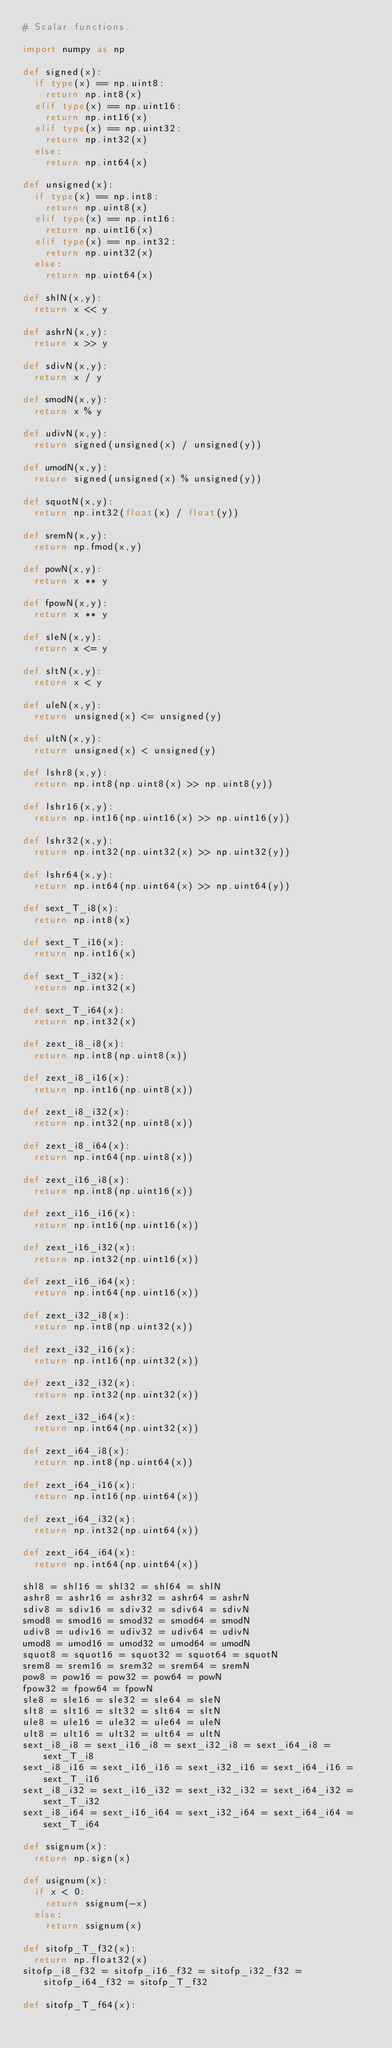<code> <loc_0><loc_0><loc_500><loc_500><_Python_># Scalar functions.

import numpy as np

def signed(x):
  if type(x) == np.uint8:
    return np.int8(x)
  elif type(x) == np.uint16:
    return np.int16(x)
  elif type(x) == np.uint32:
    return np.int32(x)
  else:
    return np.int64(x)

def unsigned(x):
  if type(x) == np.int8:
    return np.uint8(x)
  elif type(x) == np.int16:
    return np.uint16(x)
  elif type(x) == np.int32:
    return np.uint32(x)
  else:
    return np.uint64(x)

def shlN(x,y):
  return x << y

def ashrN(x,y):
  return x >> y

def sdivN(x,y):
  return x / y

def smodN(x,y):
  return x % y

def udivN(x,y):
  return signed(unsigned(x) / unsigned(y))

def umodN(x,y):
  return signed(unsigned(x) % unsigned(y))

def squotN(x,y):
  return np.int32(float(x) / float(y))

def sremN(x,y):
  return np.fmod(x,y)

def powN(x,y):
  return x ** y

def fpowN(x,y):
  return x ** y

def sleN(x,y):
  return x <= y

def sltN(x,y):
  return x < y

def uleN(x,y):
  return unsigned(x) <= unsigned(y)

def ultN(x,y):
  return unsigned(x) < unsigned(y)

def lshr8(x,y):
  return np.int8(np.uint8(x) >> np.uint8(y))

def lshr16(x,y):
  return np.int16(np.uint16(x) >> np.uint16(y))

def lshr32(x,y):
  return np.int32(np.uint32(x) >> np.uint32(y))

def lshr64(x,y):
  return np.int64(np.uint64(x) >> np.uint64(y))

def sext_T_i8(x):
  return np.int8(x)

def sext_T_i16(x):
  return np.int16(x)

def sext_T_i32(x):
  return np.int32(x)

def sext_T_i64(x):
  return np.int32(x)

def zext_i8_i8(x):
  return np.int8(np.uint8(x))

def zext_i8_i16(x):
  return np.int16(np.uint8(x))

def zext_i8_i32(x):
  return np.int32(np.uint8(x))

def zext_i8_i64(x):
  return np.int64(np.uint8(x))

def zext_i16_i8(x):
  return np.int8(np.uint16(x))

def zext_i16_i16(x):
  return np.int16(np.uint16(x))

def zext_i16_i32(x):
  return np.int32(np.uint16(x))

def zext_i16_i64(x):
  return np.int64(np.uint16(x))

def zext_i32_i8(x):
  return np.int8(np.uint32(x))

def zext_i32_i16(x):
  return np.int16(np.uint32(x))

def zext_i32_i32(x):
  return np.int32(np.uint32(x))

def zext_i32_i64(x):
  return np.int64(np.uint32(x))

def zext_i64_i8(x):
  return np.int8(np.uint64(x))

def zext_i64_i16(x):
  return np.int16(np.uint64(x))

def zext_i64_i32(x):
  return np.int32(np.uint64(x))

def zext_i64_i64(x):
  return np.int64(np.uint64(x))

shl8 = shl16 = shl32 = shl64 = shlN
ashr8 = ashr16 = ashr32 = ashr64 = ashrN
sdiv8 = sdiv16 = sdiv32 = sdiv64 = sdivN
smod8 = smod16 = smod32 = smod64 = smodN
udiv8 = udiv16 = udiv32 = udiv64 = udivN
umod8 = umod16 = umod32 = umod64 = umodN
squot8 = squot16 = squot32 = squot64 = squotN
srem8 = srem16 = srem32 = srem64 = sremN
pow8 = pow16 = pow32 = pow64 = powN
fpow32 = fpow64 = fpowN
sle8 = sle16 = sle32 = sle64 = sleN
slt8 = slt16 = slt32 = slt64 = sltN
ule8 = ule16 = ule32 = ule64 = uleN
ult8 = ult16 = ult32 = ult64 = ultN
sext_i8_i8 = sext_i16_i8 = sext_i32_i8 = sext_i64_i8 = sext_T_i8
sext_i8_i16 = sext_i16_i16 = sext_i32_i16 = sext_i64_i16 = sext_T_i16
sext_i8_i32 = sext_i16_i32 = sext_i32_i32 = sext_i64_i32 = sext_T_i32
sext_i8_i64 = sext_i16_i64 = sext_i32_i64 = sext_i64_i64 = sext_T_i64

def ssignum(x):
  return np.sign(x)

def usignum(x):
  if x < 0:
    return ssignum(-x)
  else:
    return ssignum(x)

def sitofp_T_f32(x):
  return np.float32(x)
sitofp_i8_f32 = sitofp_i16_f32 = sitofp_i32_f32 = sitofp_i64_f32 = sitofp_T_f32

def sitofp_T_f64(x):</code> 